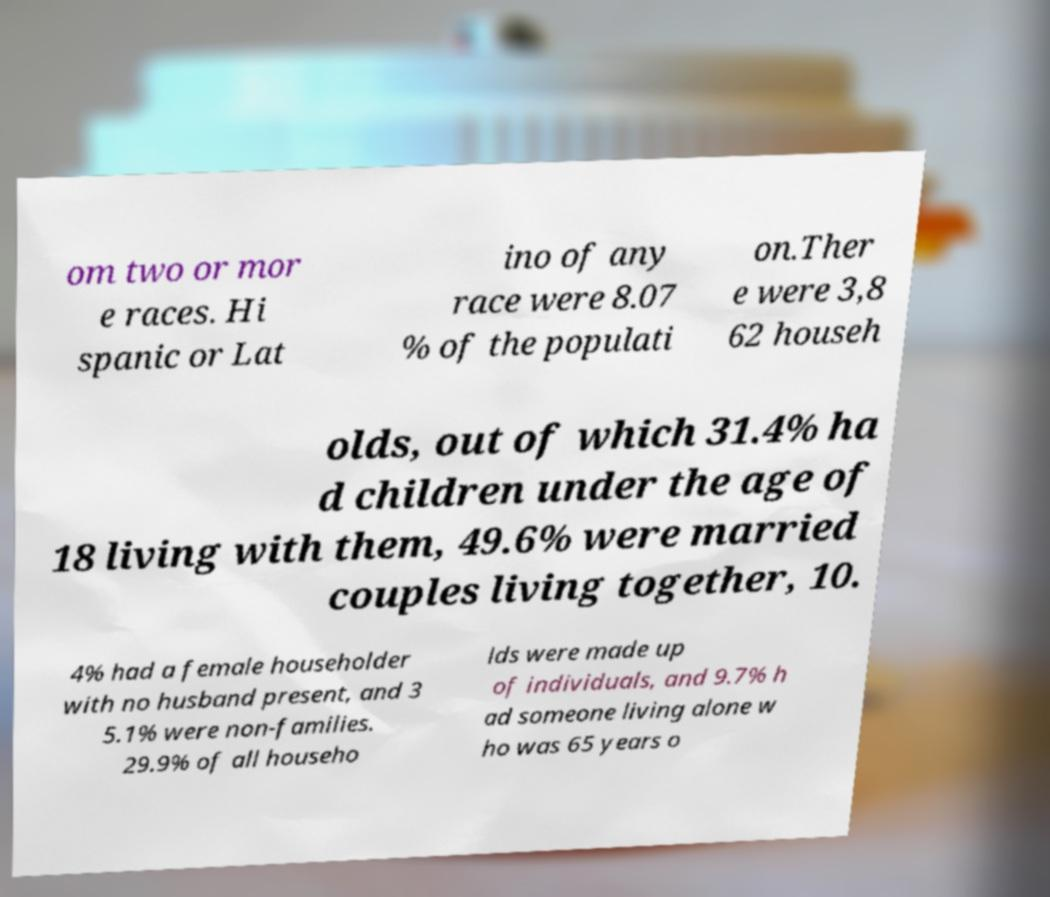Could you assist in decoding the text presented in this image and type it out clearly? om two or mor e races. Hi spanic or Lat ino of any race were 8.07 % of the populati on.Ther e were 3,8 62 househ olds, out of which 31.4% ha d children under the age of 18 living with them, 49.6% were married couples living together, 10. 4% had a female householder with no husband present, and 3 5.1% were non-families. 29.9% of all househo lds were made up of individuals, and 9.7% h ad someone living alone w ho was 65 years o 